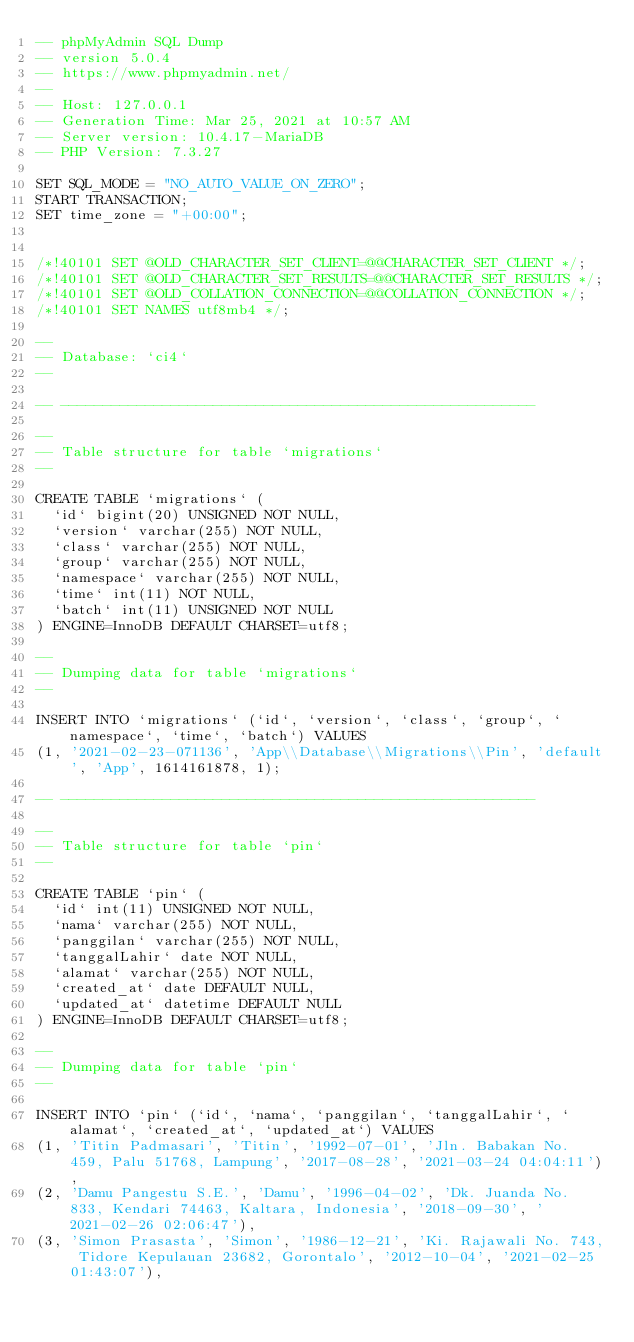<code> <loc_0><loc_0><loc_500><loc_500><_SQL_>-- phpMyAdmin SQL Dump
-- version 5.0.4
-- https://www.phpmyadmin.net/
--
-- Host: 127.0.0.1
-- Generation Time: Mar 25, 2021 at 10:57 AM
-- Server version: 10.4.17-MariaDB
-- PHP Version: 7.3.27

SET SQL_MODE = "NO_AUTO_VALUE_ON_ZERO";
START TRANSACTION;
SET time_zone = "+00:00";


/*!40101 SET @OLD_CHARACTER_SET_CLIENT=@@CHARACTER_SET_CLIENT */;
/*!40101 SET @OLD_CHARACTER_SET_RESULTS=@@CHARACTER_SET_RESULTS */;
/*!40101 SET @OLD_COLLATION_CONNECTION=@@COLLATION_CONNECTION */;
/*!40101 SET NAMES utf8mb4 */;

--
-- Database: `ci4`
--

-- --------------------------------------------------------

--
-- Table structure for table `migrations`
--

CREATE TABLE `migrations` (
  `id` bigint(20) UNSIGNED NOT NULL,
  `version` varchar(255) NOT NULL,
  `class` varchar(255) NOT NULL,
  `group` varchar(255) NOT NULL,
  `namespace` varchar(255) NOT NULL,
  `time` int(11) NOT NULL,
  `batch` int(11) UNSIGNED NOT NULL
) ENGINE=InnoDB DEFAULT CHARSET=utf8;

--
-- Dumping data for table `migrations`
--

INSERT INTO `migrations` (`id`, `version`, `class`, `group`, `namespace`, `time`, `batch`) VALUES
(1, '2021-02-23-071136', 'App\\Database\\Migrations\\Pin', 'default', 'App', 1614161878, 1);

-- --------------------------------------------------------

--
-- Table structure for table `pin`
--

CREATE TABLE `pin` (
  `id` int(11) UNSIGNED NOT NULL,
  `nama` varchar(255) NOT NULL,
  `panggilan` varchar(255) NOT NULL,
  `tanggalLahir` date NOT NULL,
  `alamat` varchar(255) NOT NULL,
  `created_at` date DEFAULT NULL,
  `updated_at` datetime DEFAULT NULL
) ENGINE=InnoDB DEFAULT CHARSET=utf8;

--
-- Dumping data for table `pin`
--

INSERT INTO `pin` (`id`, `nama`, `panggilan`, `tanggalLahir`, `alamat`, `created_at`, `updated_at`) VALUES
(1, 'Titin Padmasari', 'Titin', '1992-07-01', 'Jln. Babakan No. 459, Palu 51768, Lampung', '2017-08-28', '2021-03-24 04:04:11'),
(2, 'Damu Pangestu S.E.', 'Damu', '1996-04-02', 'Dk. Juanda No. 833, Kendari 74463, Kaltara, Indonesia', '2018-09-30', '2021-02-26 02:06:47'),
(3, 'Simon Prasasta', 'Simon', '1986-12-21', 'Ki. Rajawali No. 743, Tidore Kepulauan 23682, Gorontalo', '2012-10-04', '2021-02-25 01:43:07'),</code> 